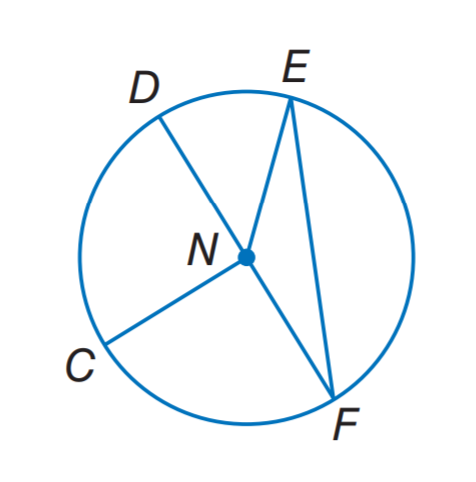Answer the mathemtical geometry problem and directly provide the correct option letter.
Question: If C N = 8. Find D N.
Choices: A: 4 B: 8 C: 12 D: 16 B 